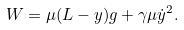Convert formula to latex. <formula><loc_0><loc_0><loc_500><loc_500>W = \mu ( L - y ) g + \gamma \mu \dot { y } ^ { 2 } .</formula> 